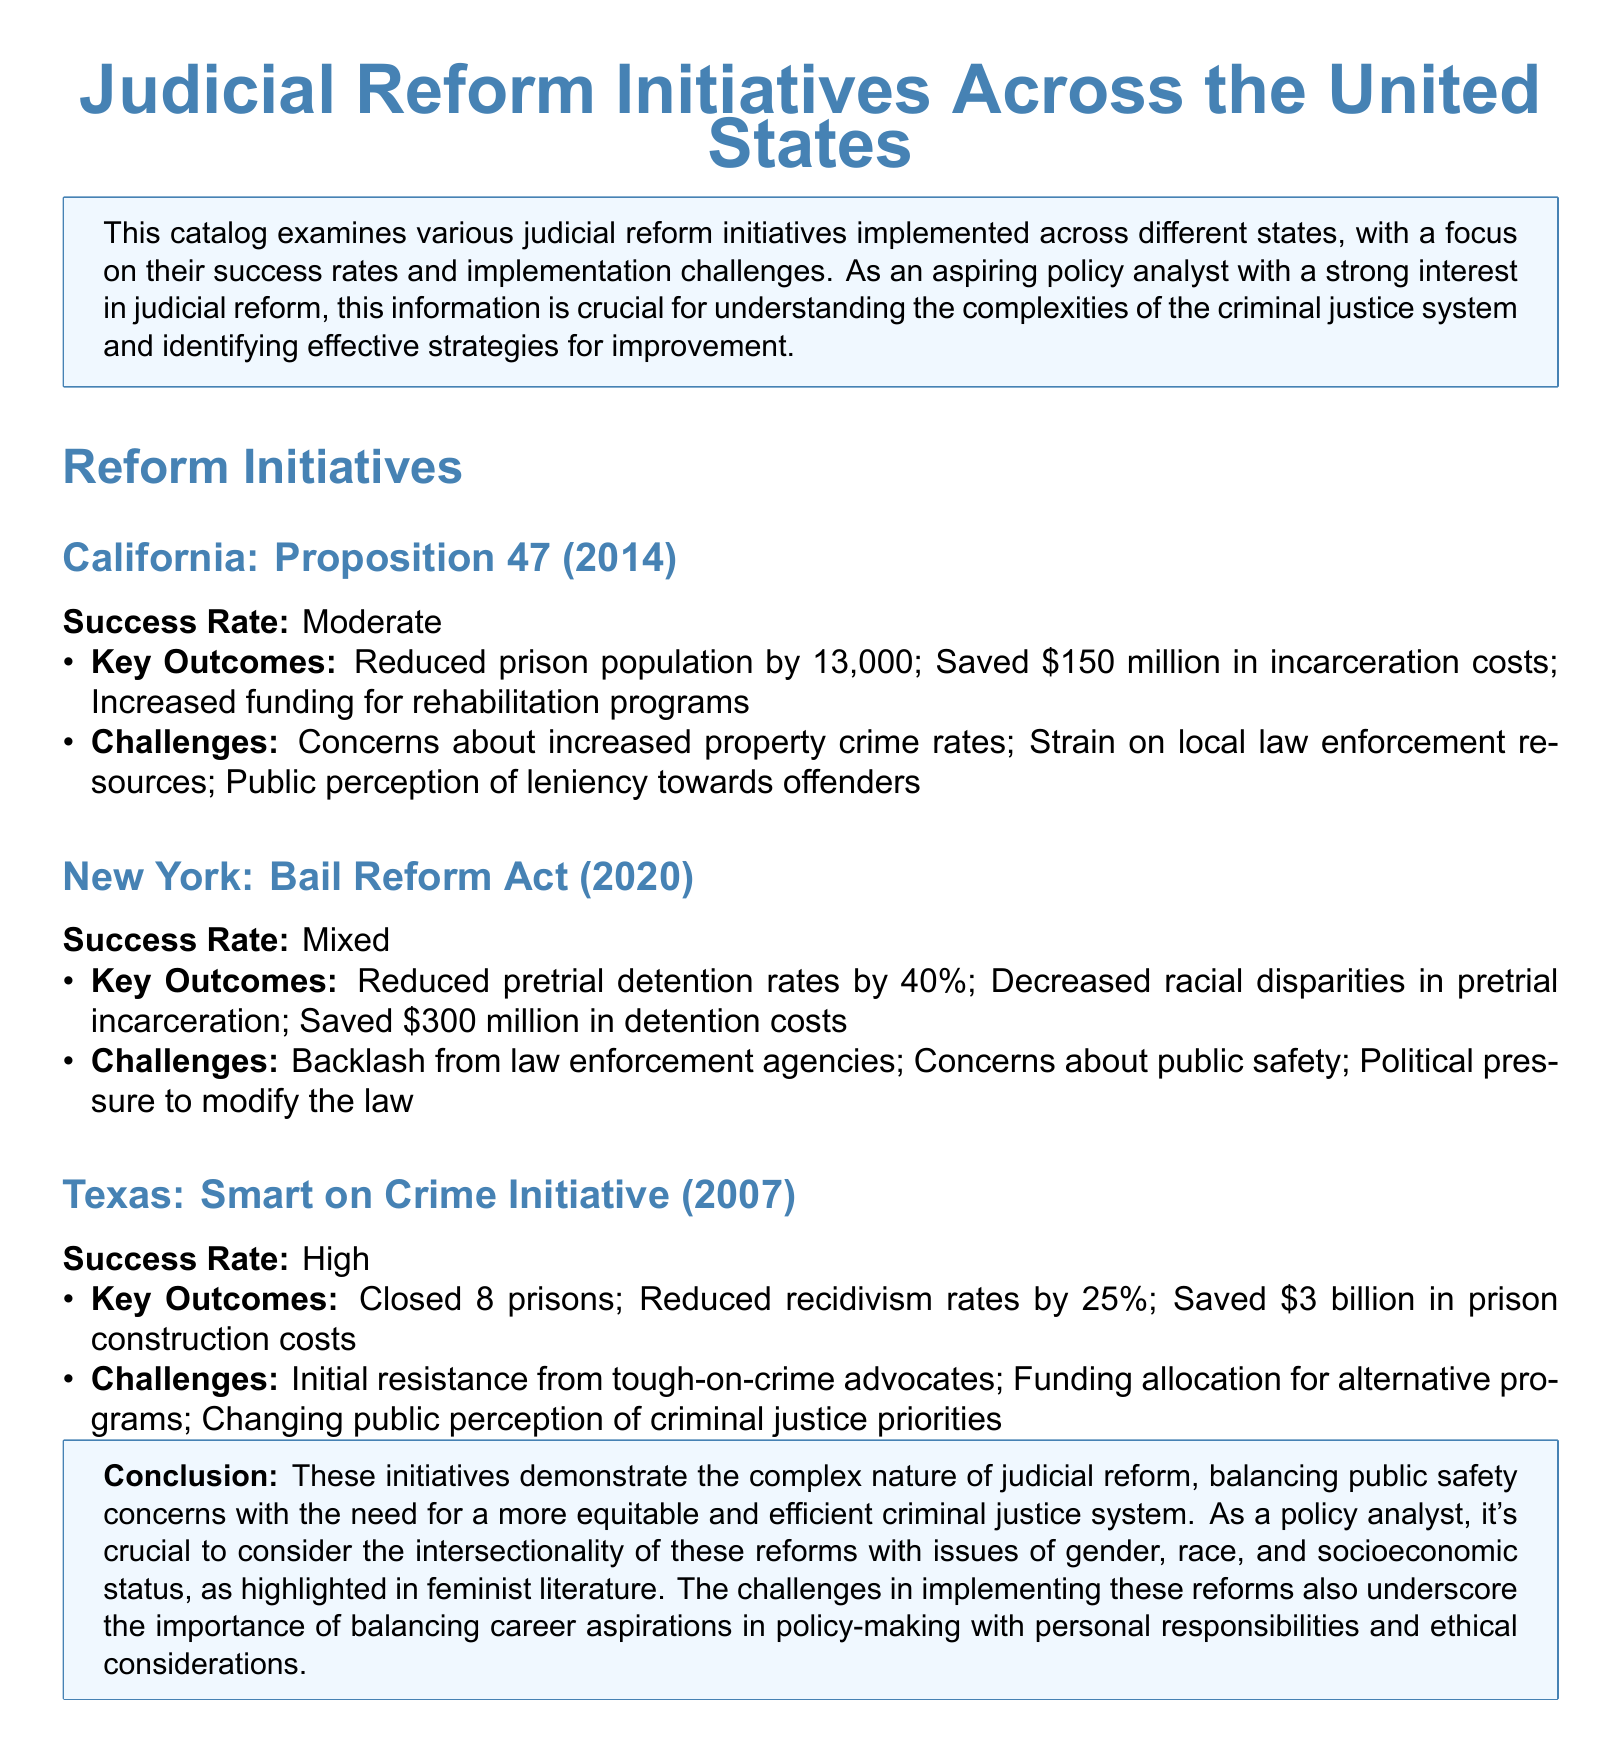What is the success rate of California's Proposition 47? The success rate is described as moderate in the document.
Answer: Moderate What was the amount saved in incarceration costs due to Proposition 47? The document states that \$150 million was saved in incarceration costs.
Answer: \$150 million How much did pretrial detention rates decrease in New York after the Bail Reform Act? The document mentions a 40% decrease in pretrial detention rates.
Answer: 40% What key outcome did Texas's Smart on Crime Initiative achieve regarding recidivism rates? The document states that recidivism rates were reduced by 25%.
Answer: 25% What was a major challenge faced by the New York Bail Reform Act? The document lists backlash from law enforcement agencies as a challenge.
Answer: Backlash from law enforcement agencies Which state initiative reduced its prison population significantly? The document indicates that California's Proposition 47 reduced the prison population.
Answer: Proposition 47 What was the overall conclusion regarding judicial reform initiatives in the document? The conclusion highlights the complex nature of judicial reforms and their intersectionality with various social issues.
Answer: Complex nature of judicial reforms What fiscal benefit did the Smart on Crime Initiative provide Texas? The document states that Texas saved \$3 billion in prison construction costs.
Answer: \$3 billion What does the document emphasize about the importance of understanding judicial reforms? It emphasizes the need to consider intersectionality with issues of gender, race, and socioeconomic status.
Answer: Intersectionality with issues of gender, race, and socioeconomic status 